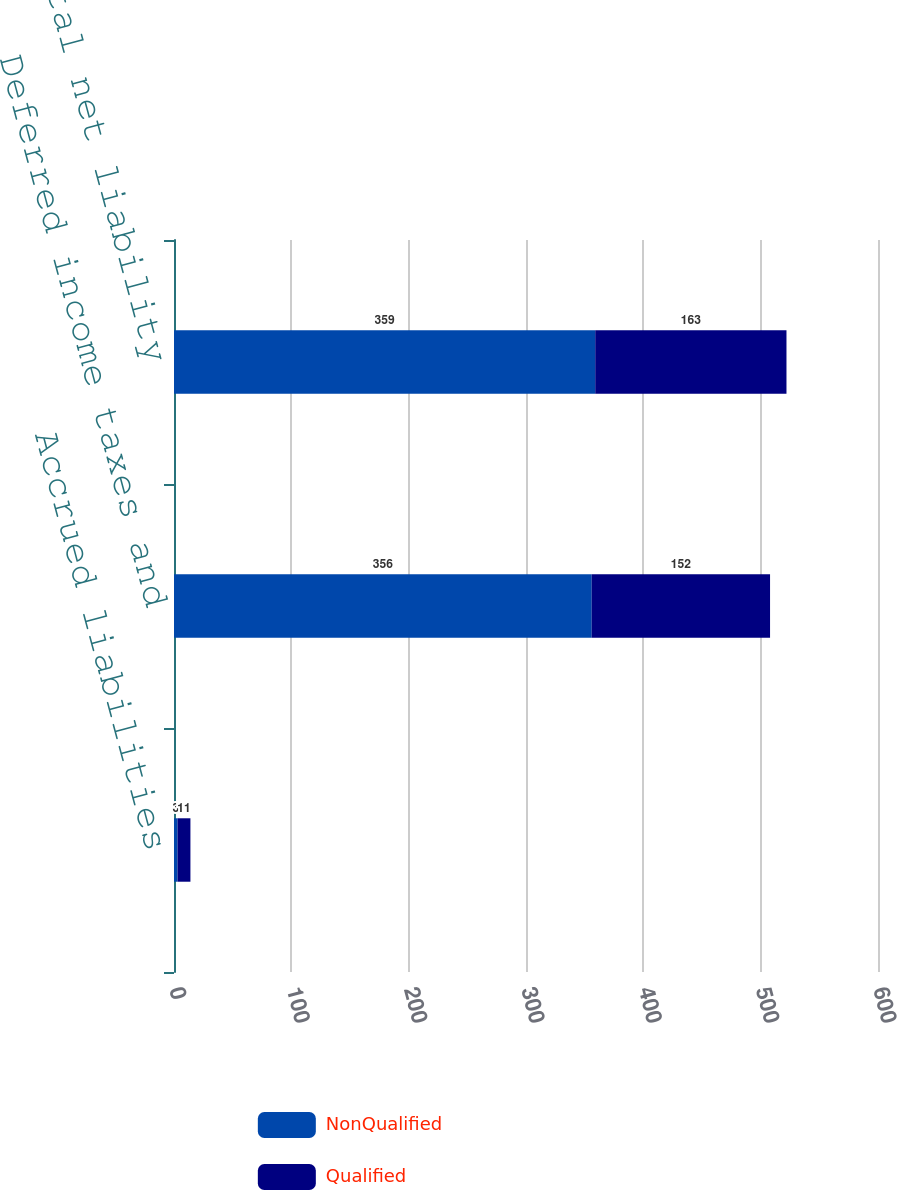Convert chart to OTSL. <chart><loc_0><loc_0><loc_500><loc_500><stacked_bar_chart><ecel><fcel>Accrued liabilities<fcel>Deferred income taxes and<fcel>Total net liability<nl><fcel>NonQualified<fcel>3<fcel>356<fcel>359<nl><fcel>Qualified<fcel>11<fcel>152<fcel>163<nl></chart> 